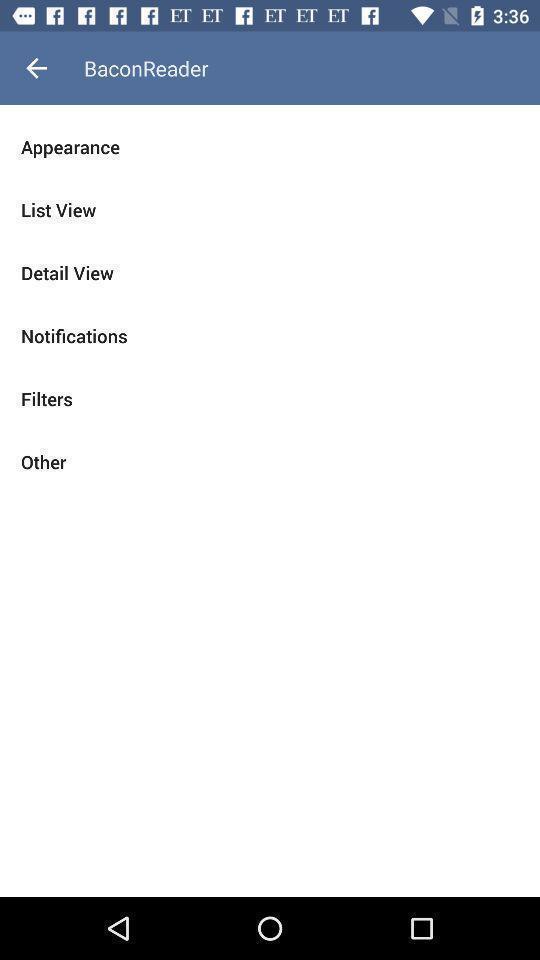What details can you identify in this image? Page showing options in a social feed related app. 